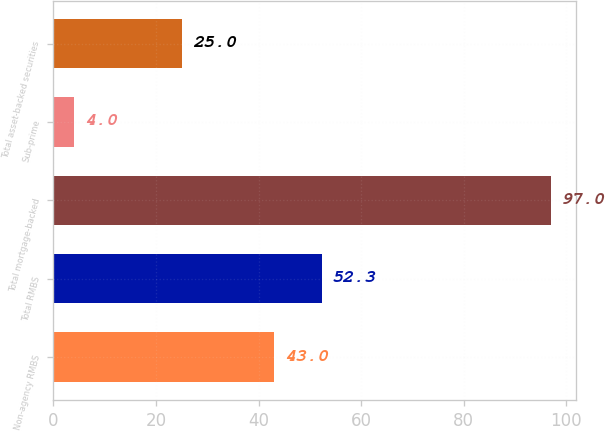<chart> <loc_0><loc_0><loc_500><loc_500><bar_chart><fcel>Non-agency RMBS<fcel>Total RMBS<fcel>Total mortgage-backed<fcel>Sub-prime<fcel>Total asset-backed securities<nl><fcel>43<fcel>52.3<fcel>97<fcel>4<fcel>25<nl></chart> 